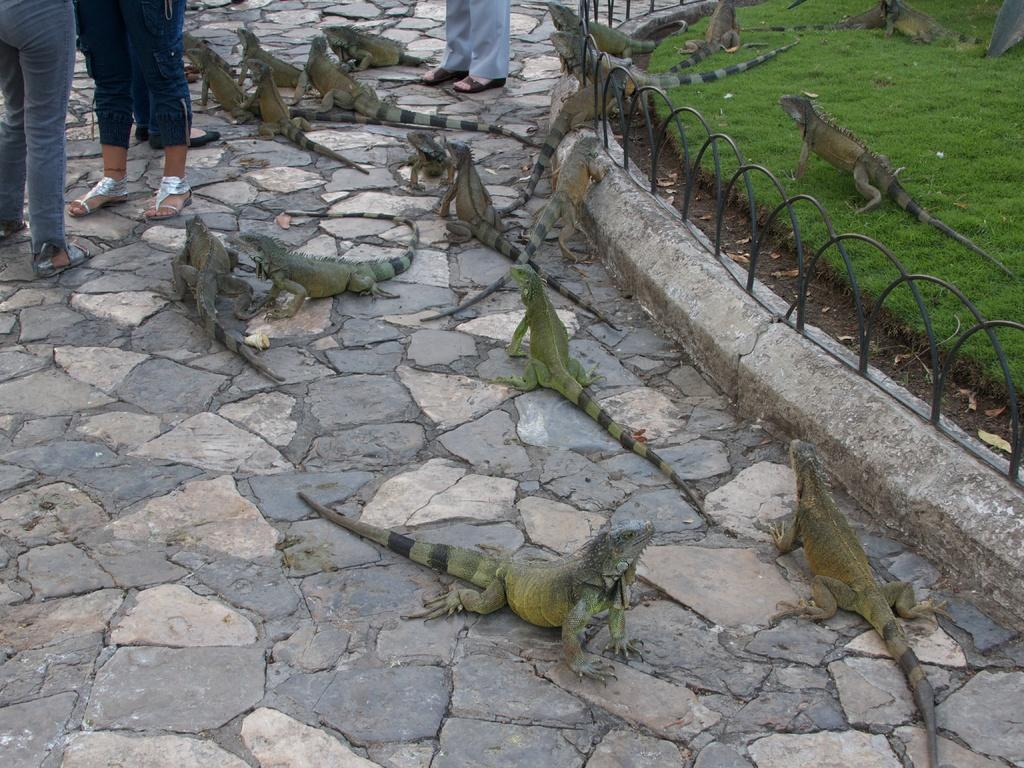What type of animals are present in the image? There are reptiles in the image. What colors are the reptiles? The reptiles are in green and brown colors. Are there any humans in the image? Yes, there are people standing in the image. What type of vegetation can be seen in the image? There is green-colored grass visible in the image. Can you describe the flight of the birds in the image? There are no birds present in the image; it features reptiles and people. What type of trees can be seen in the image? There are no trees visible in the image; it only shows reptiles, people, and green-colored grass. 